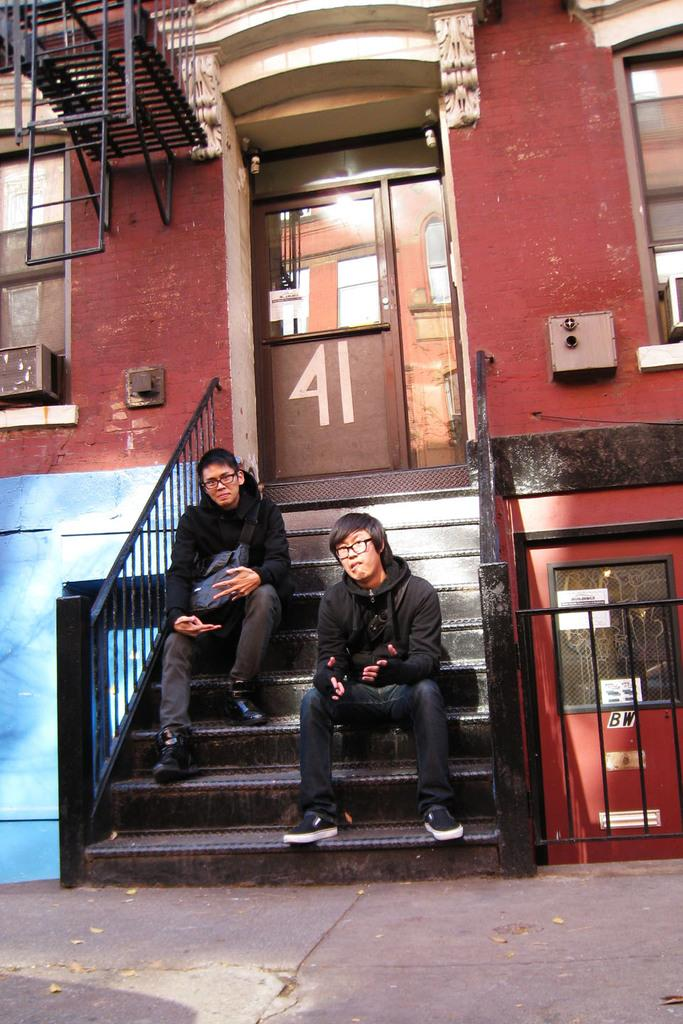How many people are sitting on the stairs in the image? There are two persons sitting on the stairs in the image. What can be seen in the background of the image? There is a building in the background of the image. What features does the building have? The building has a door and iron grilles. What is visible at the bottom of the image? There is a pathway at the bottom of the image. What type of rings can be seen on the fingers of the persons sitting on the stairs? There is no indication of rings on the fingers of the persons sitting on the stairs in the image. What is the cannon used for in the image? There is no cannon present in the image. 